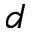<formula> <loc_0><loc_0><loc_500><loc_500>d</formula> 